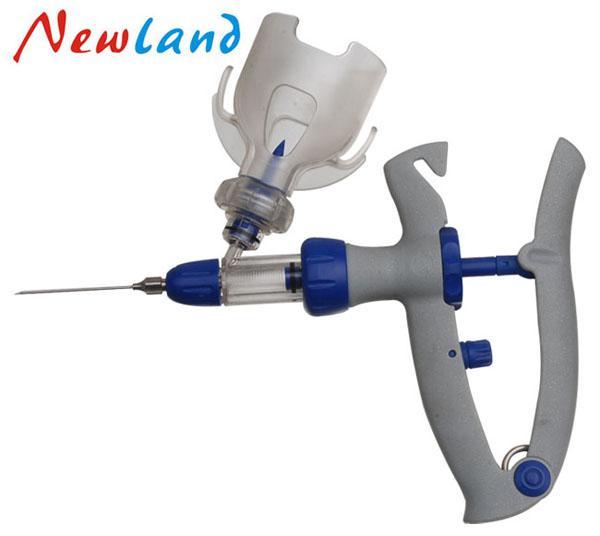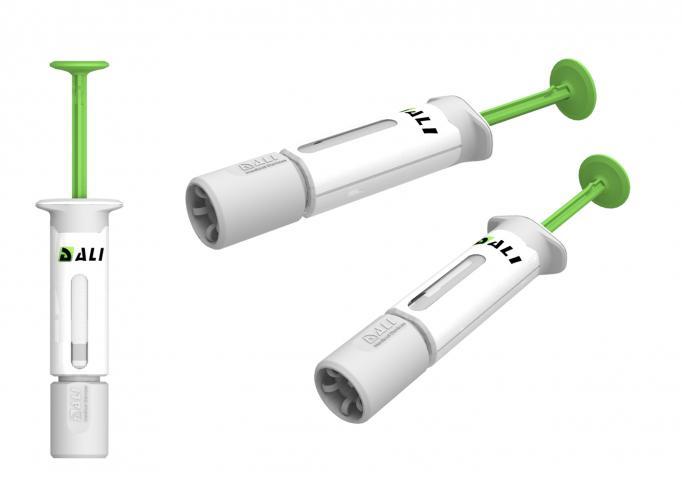The first image is the image on the left, the second image is the image on the right. Given the left and right images, does the statement "There are three objects with plungers in the image on the right." hold true? Answer yes or no. Yes. 